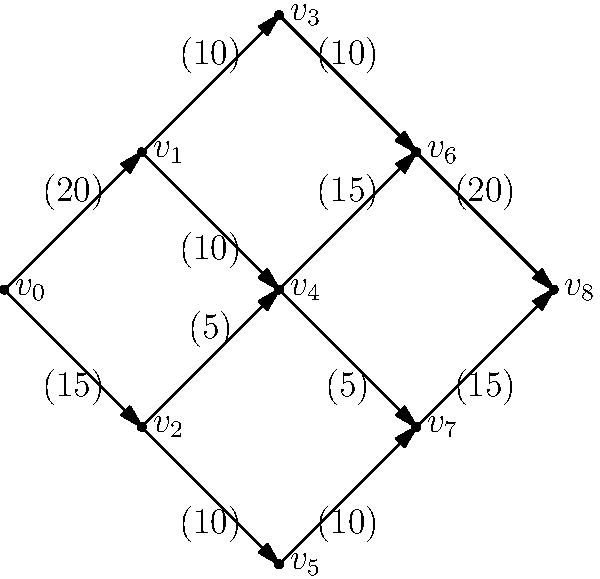Given the network flow diagram representing different routes and capacities for guest accommodation during a peak football season, what is the maximum number of guests that can be accommodated per day? Each edge is labeled with its capacity (number of guests), and the goal is to maximize the flow from $v_0$ (source) to $v_8$ (sink). To find the maximum flow in this network, we'll use the Ford-Fulkerson algorithm:

1) Initialize all flows to 0.
2) Find an augmenting path from source to sink:
   Path 1: $v_0 \rightarrow v_1 \rightarrow v_3 \rightarrow v_6 \rightarrow v_8$ (min capacity 10)
   Flow: 10
3) Update residual graph and find another path:
   Path 2: $v_0 \rightarrow v_1 \rightarrow v_4 \rightarrow v_6 \rightarrow v_8$ (min capacity 10)
   Flow: 10 + 10 = 20
4) Update and find another path:
   Path 3: $v_0 \rightarrow v_2 \rightarrow v_4 \rightarrow v_7 \rightarrow v_8$ (min capacity 5)
   Flow: 20 + 5 = 25
5) Update and find another path:
   Path 4: $v_0 \rightarrow v_2 \rightarrow v_5 \rightarrow v_7 \rightarrow v_8$ (min capacity 10)
   Flow: 25 + 10 = 35

No more augmenting paths exist, so the maximum flow is 35.

This means the hotel can accommodate a maximum of 35 guests per day during peak football seasons using the given network of routes and room allocations.
Answer: 35 guests 